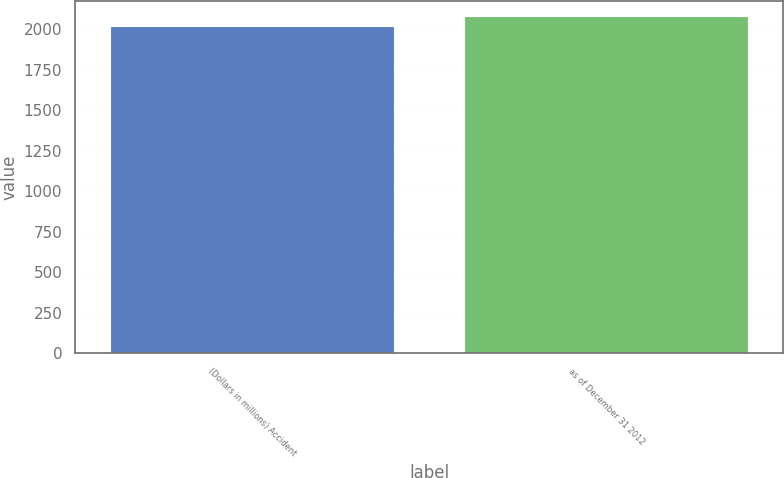<chart> <loc_0><loc_0><loc_500><loc_500><bar_chart><fcel>(Dollars in millions) Accident<fcel>as of December 31 2012<nl><fcel>2010<fcel>2072<nl></chart> 